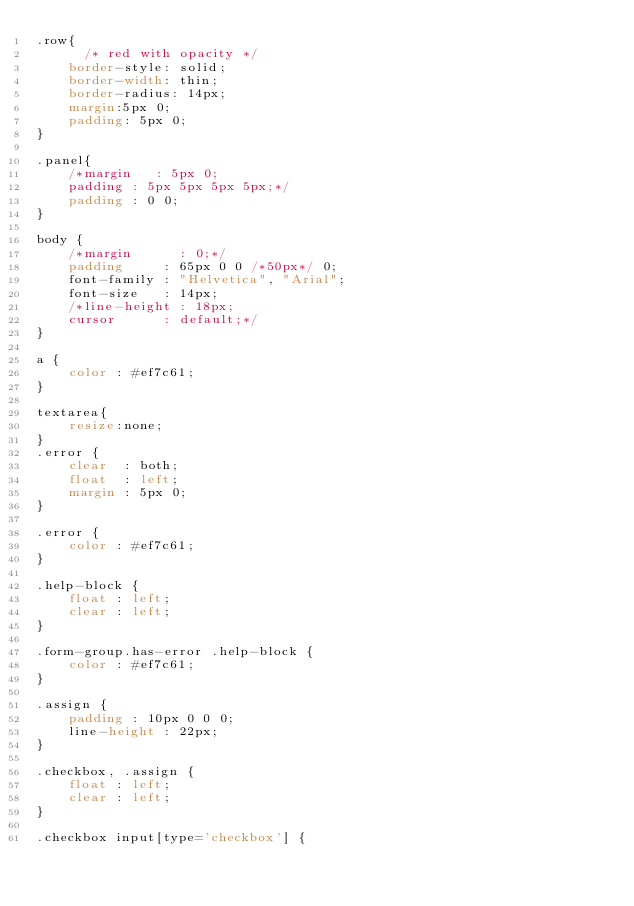Convert code to text. <code><loc_0><loc_0><loc_500><loc_500><_CSS_>.row{
	  /* red with opacity */
	border-style: solid;
	border-width: thin;
	border-radius: 14px;
	margin:5px 0;
	padding: 5px 0;
}

.panel{
	/*margin   : 5px 0;
	padding : 5px 5px 5px 5px;*/
	padding : 0 0;
}

body {
    /*margin      : 0;*/
    padding     : 65px 0 0 /*50px*/ 0;
    font-family : "Helvetica", "Arial";
    font-size   : 14px;
    /*line-height : 18px;
    cursor      : default;*/
}

a {
    color : #ef7c61;
}

textarea{
	resize:none;
}
.error {
    clear  : both;
    float  : left;
    margin : 5px 0;
}

.error {
    color : #ef7c61;
}

.help-block {
    float : left;
    clear : left;
}

.form-group.has-error .help-block {
    color : #ef7c61;
}

.assign {
    padding : 10px 0 0 0;
    line-height : 22px;
}

.checkbox, .assign {
    float : left;
    clear : left;
}

.checkbox input[type='checkbox'] {</code> 